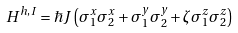Convert formula to latex. <formula><loc_0><loc_0><loc_500><loc_500>H ^ { h , I } = \hbar { J } \left ( \sigma ^ { x } _ { 1 } \sigma ^ { x } _ { 2 } + \sigma ^ { y } _ { 1 } \sigma ^ { y } _ { 2 } + \zeta \sigma ^ { z } _ { 1 } \sigma ^ { z } _ { 2 } \right )</formula> 